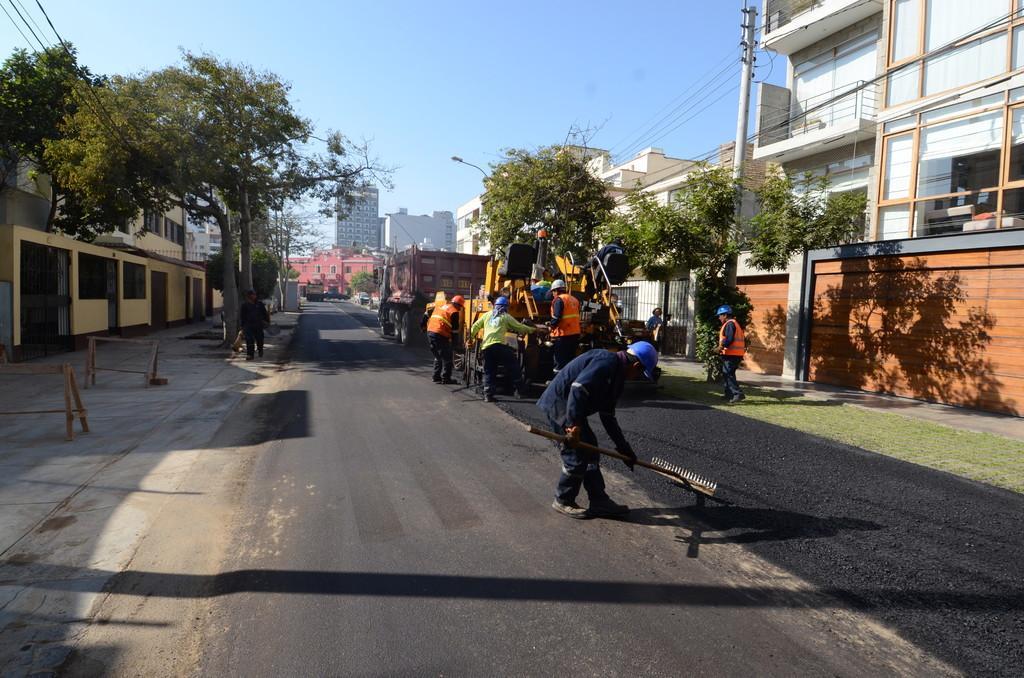Describe this image in one or two sentences. In this image in the front there are persons. In the background there are buildings, trees and there are vehicles. On the left side there are objects which are made up of wood. On the right side there is a building and in front of the building there is a pole and there are wires. 